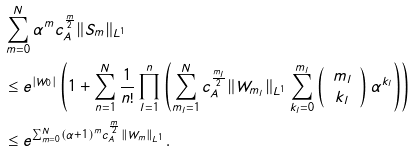Convert formula to latex. <formula><loc_0><loc_0><loc_500><loc_500>& \sum _ { m = 0 } ^ { N } \alpha ^ { m } c _ { A } ^ { \frac { m } { 2 } } \| S _ { m } \| _ { L ^ { 1 } } \\ & \leq e ^ { | W _ { 0 } | } \left ( 1 + \sum _ { n = 1 } ^ { N } \frac { 1 } { n ! } \prod _ { l = 1 } ^ { n } \left ( \sum _ { m _ { l } = 1 } ^ { N } c _ { A } ^ { \frac { m _ { l } } { 2 } } \| W _ { m _ { l } } \| _ { L ^ { 1 } } \sum _ { k _ { l } = 0 } ^ { m _ { l } } \left ( \begin{array} { c } m _ { l } \\ k _ { l } \end{array} \right ) \alpha ^ { k _ { l } } \right ) \right ) \\ & \leq e ^ { \sum _ { m = 0 } ^ { N } ( \alpha + 1 ) ^ { m } c _ { A } ^ { \frac { m } { 2 } } \| W _ { m } \| _ { L ^ { 1 } } } .</formula> 